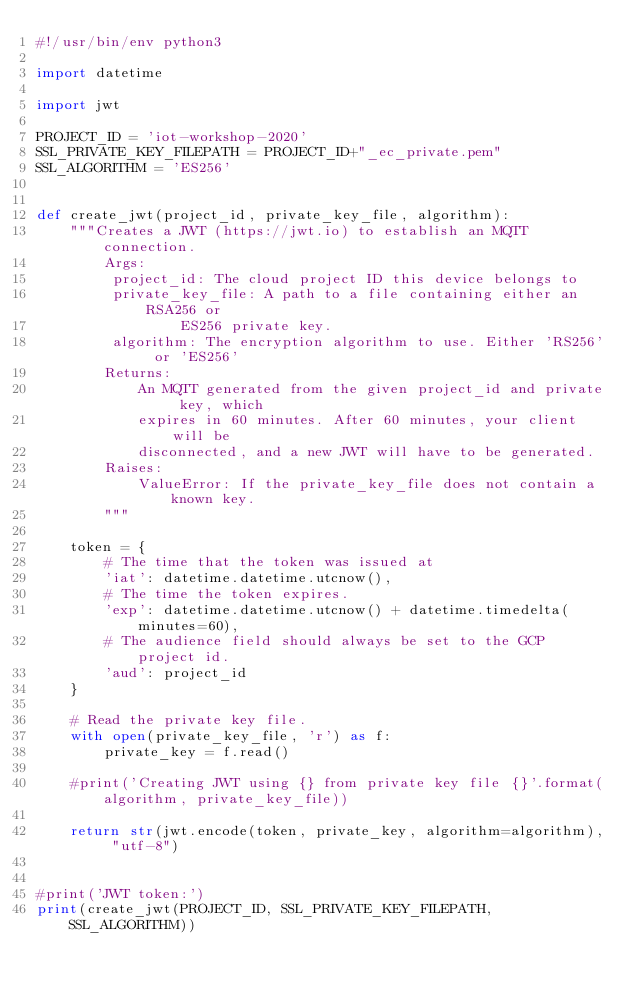<code> <loc_0><loc_0><loc_500><loc_500><_Python_>#!/usr/bin/env python3

import datetime

import jwt

PROJECT_ID = 'iot-workshop-2020'
SSL_PRIVATE_KEY_FILEPATH = PROJECT_ID+"_ec_private.pem"
SSL_ALGORITHM = 'ES256'


def create_jwt(project_id, private_key_file, algorithm):
    """Creates a JWT (https://jwt.io) to establish an MQTT connection.
        Args:
         project_id: The cloud project ID this device belongs to
         private_key_file: A path to a file containing either an RSA256 or
                 ES256 private key.
         algorithm: The encryption algorithm to use. Either 'RS256' or 'ES256'
        Returns:
            An MQTT generated from the given project_id and private key, which
            expires in 60 minutes. After 60 minutes, your client will be
            disconnected, and a new JWT will have to be generated.
        Raises:
            ValueError: If the private_key_file does not contain a known key.
        """

    token = {
        # The time that the token was issued at
        'iat': datetime.datetime.utcnow(),
        # The time the token expires.
        'exp': datetime.datetime.utcnow() + datetime.timedelta(minutes=60),
        # The audience field should always be set to the GCP project id.
        'aud': project_id
    }

    # Read the private key file.
    with open(private_key_file, 'r') as f:
        private_key = f.read()

    #print('Creating JWT using {} from private key file {}'.format(algorithm, private_key_file))

    return str(jwt.encode(token, private_key, algorithm=algorithm), "utf-8")


#print('JWT token:')
print(create_jwt(PROJECT_ID, SSL_PRIVATE_KEY_FILEPATH, SSL_ALGORITHM))
</code> 